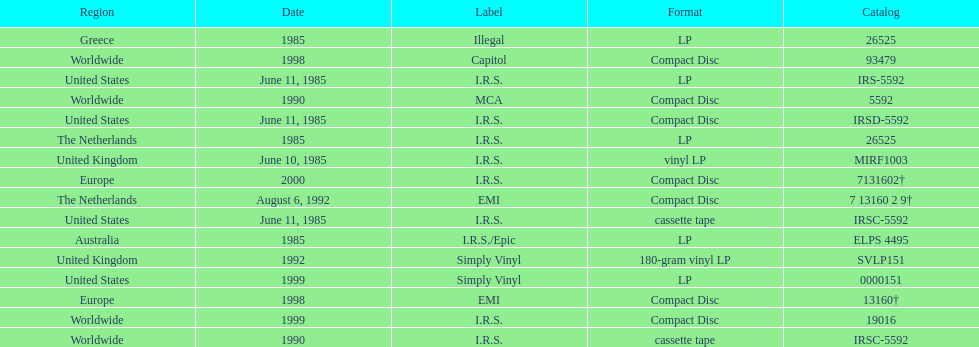Which region was the last to release? Europe. 